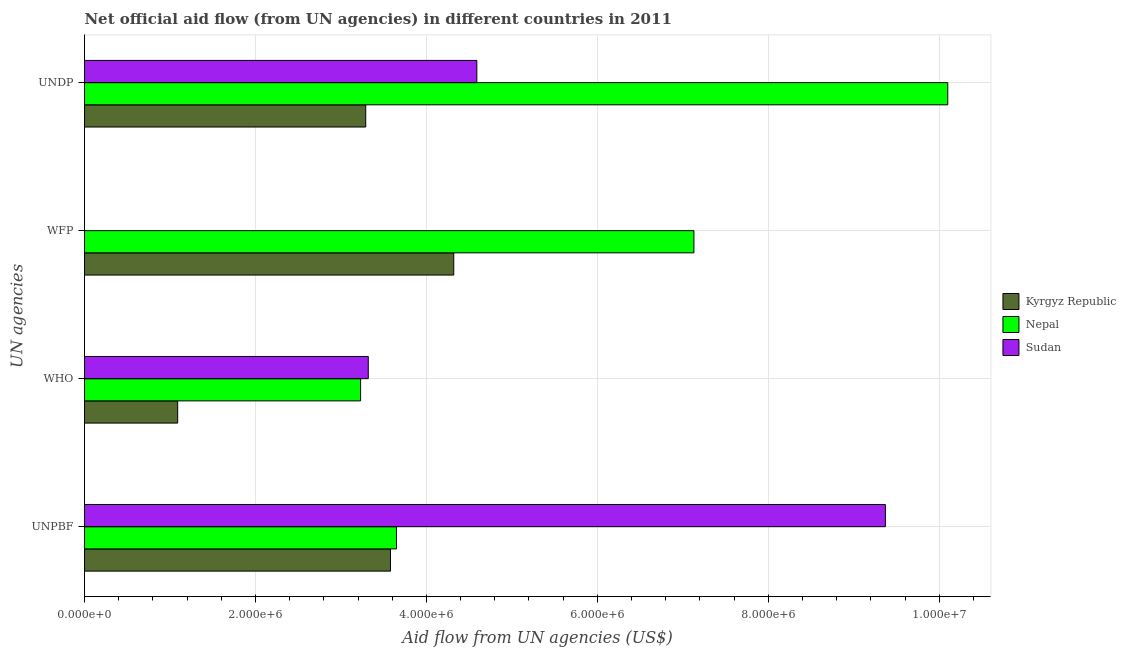How many different coloured bars are there?
Your answer should be compact. 3. Are the number of bars per tick equal to the number of legend labels?
Provide a short and direct response. No. How many bars are there on the 4th tick from the top?
Give a very brief answer. 3. How many bars are there on the 1st tick from the bottom?
Offer a terse response. 3. What is the label of the 4th group of bars from the top?
Your answer should be very brief. UNPBF. What is the amount of aid given by wfp in Sudan?
Offer a terse response. 0. Across all countries, what is the maximum amount of aid given by unpbf?
Make the answer very short. 9.37e+06. Across all countries, what is the minimum amount of aid given by unpbf?
Keep it short and to the point. 3.58e+06. In which country was the amount of aid given by undp maximum?
Ensure brevity in your answer.  Nepal. What is the total amount of aid given by unpbf in the graph?
Make the answer very short. 1.66e+07. What is the difference between the amount of aid given by unpbf in Sudan and that in Kyrgyz Republic?
Your answer should be compact. 5.79e+06. What is the difference between the amount of aid given by unpbf in Sudan and the amount of aid given by who in Nepal?
Your answer should be very brief. 6.14e+06. What is the average amount of aid given by undp per country?
Provide a short and direct response. 5.99e+06. What is the difference between the amount of aid given by undp and amount of aid given by who in Nepal?
Your response must be concise. 6.87e+06. What is the ratio of the amount of aid given by who in Nepal to that in Kyrgyz Republic?
Give a very brief answer. 2.96. Is the difference between the amount of aid given by who in Nepal and Kyrgyz Republic greater than the difference between the amount of aid given by undp in Nepal and Kyrgyz Republic?
Your response must be concise. No. What is the difference between the highest and the lowest amount of aid given by unpbf?
Offer a very short reply. 5.79e+06. Is the sum of the amount of aid given by undp in Sudan and Kyrgyz Republic greater than the maximum amount of aid given by unpbf across all countries?
Give a very brief answer. No. Is it the case that in every country, the sum of the amount of aid given by unpbf and amount of aid given by wfp is greater than the sum of amount of aid given by who and amount of aid given by undp?
Make the answer very short. No. Is it the case that in every country, the sum of the amount of aid given by unpbf and amount of aid given by who is greater than the amount of aid given by wfp?
Provide a succinct answer. No. How many countries are there in the graph?
Give a very brief answer. 3. What is the difference between two consecutive major ticks on the X-axis?
Make the answer very short. 2.00e+06. How are the legend labels stacked?
Ensure brevity in your answer.  Vertical. What is the title of the graph?
Make the answer very short. Net official aid flow (from UN agencies) in different countries in 2011. Does "Israel" appear as one of the legend labels in the graph?
Your answer should be very brief. No. What is the label or title of the X-axis?
Offer a terse response. Aid flow from UN agencies (US$). What is the label or title of the Y-axis?
Offer a very short reply. UN agencies. What is the Aid flow from UN agencies (US$) of Kyrgyz Republic in UNPBF?
Provide a succinct answer. 3.58e+06. What is the Aid flow from UN agencies (US$) in Nepal in UNPBF?
Provide a succinct answer. 3.65e+06. What is the Aid flow from UN agencies (US$) of Sudan in UNPBF?
Ensure brevity in your answer.  9.37e+06. What is the Aid flow from UN agencies (US$) in Kyrgyz Republic in WHO?
Provide a short and direct response. 1.09e+06. What is the Aid flow from UN agencies (US$) of Nepal in WHO?
Keep it short and to the point. 3.23e+06. What is the Aid flow from UN agencies (US$) of Sudan in WHO?
Offer a terse response. 3.32e+06. What is the Aid flow from UN agencies (US$) in Kyrgyz Republic in WFP?
Provide a succinct answer. 4.32e+06. What is the Aid flow from UN agencies (US$) of Nepal in WFP?
Provide a succinct answer. 7.13e+06. What is the Aid flow from UN agencies (US$) of Kyrgyz Republic in UNDP?
Provide a short and direct response. 3.29e+06. What is the Aid flow from UN agencies (US$) of Nepal in UNDP?
Provide a succinct answer. 1.01e+07. What is the Aid flow from UN agencies (US$) of Sudan in UNDP?
Make the answer very short. 4.59e+06. Across all UN agencies, what is the maximum Aid flow from UN agencies (US$) of Kyrgyz Republic?
Keep it short and to the point. 4.32e+06. Across all UN agencies, what is the maximum Aid flow from UN agencies (US$) in Nepal?
Give a very brief answer. 1.01e+07. Across all UN agencies, what is the maximum Aid flow from UN agencies (US$) of Sudan?
Offer a very short reply. 9.37e+06. Across all UN agencies, what is the minimum Aid flow from UN agencies (US$) of Kyrgyz Republic?
Give a very brief answer. 1.09e+06. Across all UN agencies, what is the minimum Aid flow from UN agencies (US$) in Nepal?
Offer a very short reply. 3.23e+06. What is the total Aid flow from UN agencies (US$) in Kyrgyz Republic in the graph?
Ensure brevity in your answer.  1.23e+07. What is the total Aid flow from UN agencies (US$) of Nepal in the graph?
Provide a short and direct response. 2.41e+07. What is the total Aid flow from UN agencies (US$) of Sudan in the graph?
Offer a very short reply. 1.73e+07. What is the difference between the Aid flow from UN agencies (US$) of Kyrgyz Republic in UNPBF and that in WHO?
Provide a succinct answer. 2.49e+06. What is the difference between the Aid flow from UN agencies (US$) of Nepal in UNPBF and that in WHO?
Offer a very short reply. 4.20e+05. What is the difference between the Aid flow from UN agencies (US$) in Sudan in UNPBF and that in WHO?
Keep it short and to the point. 6.05e+06. What is the difference between the Aid flow from UN agencies (US$) in Kyrgyz Republic in UNPBF and that in WFP?
Ensure brevity in your answer.  -7.40e+05. What is the difference between the Aid flow from UN agencies (US$) in Nepal in UNPBF and that in WFP?
Offer a terse response. -3.48e+06. What is the difference between the Aid flow from UN agencies (US$) in Kyrgyz Republic in UNPBF and that in UNDP?
Your answer should be very brief. 2.90e+05. What is the difference between the Aid flow from UN agencies (US$) in Nepal in UNPBF and that in UNDP?
Provide a succinct answer. -6.45e+06. What is the difference between the Aid flow from UN agencies (US$) in Sudan in UNPBF and that in UNDP?
Offer a very short reply. 4.78e+06. What is the difference between the Aid flow from UN agencies (US$) in Kyrgyz Republic in WHO and that in WFP?
Make the answer very short. -3.23e+06. What is the difference between the Aid flow from UN agencies (US$) in Nepal in WHO and that in WFP?
Make the answer very short. -3.90e+06. What is the difference between the Aid flow from UN agencies (US$) of Kyrgyz Republic in WHO and that in UNDP?
Offer a terse response. -2.20e+06. What is the difference between the Aid flow from UN agencies (US$) of Nepal in WHO and that in UNDP?
Provide a succinct answer. -6.87e+06. What is the difference between the Aid flow from UN agencies (US$) of Sudan in WHO and that in UNDP?
Your response must be concise. -1.27e+06. What is the difference between the Aid flow from UN agencies (US$) of Kyrgyz Republic in WFP and that in UNDP?
Offer a very short reply. 1.03e+06. What is the difference between the Aid flow from UN agencies (US$) in Nepal in WFP and that in UNDP?
Give a very brief answer. -2.97e+06. What is the difference between the Aid flow from UN agencies (US$) in Kyrgyz Republic in UNPBF and the Aid flow from UN agencies (US$) in Nepal in WHO?
Provide a short and direct response. 3.50e+05. What is the difference between the Aid flow from UN agencies (US$) of Nepal in UNPBF and the Aid flow from UN agencies (US$) of Sudan in WHO?
Your answer should be compact. 3.30e+05. What is the difference between the Aid flow from UN agencies (US$) in Kyrgyz Republic in UNPBF and the Aid flow from UN agencies (US$) in Nepal in WFP?
Keep it short and to the point. -3.55e+06. What is the difference between the Aid flow from UN agencies (US$) of Kyrgyz Republic in UNPBF and the Aid flow from UN agencies (US$) of Nepal in UNDP?
Give a very brief answer. -6.52e+06. What is the difference between the Aid flow from UN agencies (US$) of Kyrgyz Republic in UNPBF and the Aid flow from UN agencies (US$) of Sudan in UNDP?
Ensure brevity in your answer.  -1.01e+06. What is the difference between the Aid flow from UN agencies (US$) of Nepal in UNPBF and the Aid flow from UN agencies (US$) of Sudan in UNDP?
Provide a succinct answer. -9.40e+05. What is the difference between the Aid flow from UN agencies (US$) of Kyrgyz Republic in WHO and the Aid flow from UN agencies (US$) of Nepal in WFP?
Offer a very short reply. -6.04e+06. What is the difference between the Aid flow from UN agencies (US$) in Kyrgyz Republic in WHO and the Aid flow from UN agencies (US$) in Nepal in UNDP?
Ensure brevity in your answer.  -9.01e+06. What is the difference between the Aid flow from UN agencies (US$) in Kyrgyz Republic in WHO and the Aid flow from UN agencies (US$) in Sudan in UNDP?
Provide a succinct answer. -3.50e+06. What is the difference between the Aid flow from UN agencies (US$) of Nepal in WHO and the Aid flow from UN agencies (US$) of Sudan in UNDP?
Provide a short and direct response. -1.36e+06. What is the difference between the Aid flow from UN agencies (US$) of Kyrgyz Republic in WFP and the Aid flow from UN agencies (US$) of Nepal in UNDP?
Offer a terse response. -5.78e+06. What is the difference between the Aid flow from UN agencies (US$) of Nepal in WFP and the Aid flow from UN agencies (US$) of Sudan in UNDP?
Give a very brief answer. 2.54e+06. What is the average Aid flow from UN agencies (US$) of Kyrgyz Republic per UN agencies?
Provide a short and direct response. 3.07e+06. What is the average Aid flow from UN agencies (US$) in Nepal per UN agencies?
Give a very brief answer. 6.03e+06. What is the average Aid flow from UN agencies (US$) in Sudan per UN agencies?
Give a very brief answer. 4.32e+06. What is the difference between the Aid flow from UN agencies (US$) of Kyrgyz Republic and Aid flow from UN agencies (US$) of Sudan in UNPBF?
Your answer should be very brief. -5.79e+06. What is the difference between the Aid flow from UN agencies (US$) of Nepal and Aid flow from UN agencies (US$) of Sudan in UNPBF?
Your answer should be compact. -5.72e+06. What is the difference between the Aid flow from UN agencies (US$) in Kyrgyz Republic and Aid flow from UN agencies (US$) in Nepal in WHO?
Ensure brevity in your answer.  -2.14e+06. What is the difference between the Aid flow from UN agencies (US$) in Kyrgyz Republic and Aid flow from UN agencies (US$) in Sudan in WHO?
Your response must be concise. -2.23e+06. What is the difference between the Aid flow from UN agencies (US$) of Kyrgyz Republic and Aid flow from UN agencies (US$) of Nepal in WFP?
Provide a succinct answer. -2.81e+06. What is the difference between the Aid flow from UN agencies (US$) of Kyrgyz Republic and Aid flow from UN agencies (US$) of Nepal in UNDP?
Provide a short and direct response. -6.81e+06. What is the difference between the Aid flow from UN agencies (US$) in Kyrgyz Republic and Aid flow from UN agencies (US$) in Sudan in UNDP?
Your answer should be very brief. -1.30e+06. What is the difference between the Aid flow from UN agencies (US$) of Nepal and Aid flow from UN agencies (US$) of Sudan in UNDP?
Offer a very short reply. 5.51e+06. What is the ratio of the Aid flow from UN agencies (US$) of Kyrgyz Republic in UNPBF to that in WHO?
Provide a short and direct response. 3.28. What is the ratio of the Aid flow from UN agencies (US$) of Nepal in UNPBF to that in WHO?
Ensure brevity in your answer.  1.13. What is the ratio of the Aid flow from UN agencies (US$) of Sudan in UNPBF to that in WHO?
Keep it short and to the point. 2.82. What is the ratio of the Aid flow from UN agencies (US$) in Kyrgyz Republic in UNPBF to that in WFP?
Your answer should be very brief. 0.83. What is the ratio of the Aid flow from UN agencies (US$) in Nepal in UNPBF to that in WFP?
Keep it short and to the point. 0.51. What is the ratio of the Aid flow from UN agencies (US$) in Kyrgyz Republic in UNPBF to that in UNDP?
Your answer should be very brief. 1.09. What is the ratio of the Aid flow from UN agencies (US$) in Nepal in UNPBF to that in UNDP?
Provide a succinct answer. 0.36. What is the ratio of the Aid flow from UN agencies (US$) in Sudan in UNPBF to that in UNDP?
Offer a terse response. 2.04. What is the ratio of the Aid flow from UN agencies (US$) of Kyrgyz Republic in WHO to that in WFP?
Offer a very short reply. 0.25. What is the ratio of the Aid flow from UN agencies (US$) in Nepal in WHO to that in WFP?
Give a very brief answer. 0.45. What is the ratio of the Aid flow from UN agencies (US$) in Kyrgyz Republic in WHO to that in UNDP?
Provide a short and direct response. 0.33. What is the ratio of the Aid flow from UN agencies (US$) in Nepal in WHO to that in UNDP?
Provide a succinct answer. 0.32. What is the ratio of the Aid flow from UN agencies (US$) of Sudan in WHO to that in UNDP?
Provide a short and direct response. 0.72. What is the ratio of the Aid flow from UN agencies (US$) of Kyrgyz Republic in WFP to that in UNDP?
Your answer should be compact. 1.31. What is the ratio of the Aid flow from UN agencies (US$) of Nepal in WFP to that in UNDP?
Your answer should be compact. 0.71. What is the difference between the highest and the second highest Aid flow from UN agencies (US$) in Kyrgyz Republic?
Keep it short and to the point. 7.40e+05. What is the difference between the highest and the second highest Aid flow from UN agencies (US$) in Nepal?
Offer a terse response. 2.97e+06. What is the difference between the highest and the second highest Aid flow from UN agencies (US$) of Sudan?
Your answer should be compact. 4.78e+06. What is the difference between the highest and the lowest Aid flow from UN agencies (US$) in Kyrgyz Republic?
Your response must be concise. 3.23e+06. What is the difference between the highest and the lowest Aid flow from UN agencies (US$) of Nepal?
Your answer should be compact. 6.87e+06. What is the difference between the highest and the lowest Aid flow from UN agencies (US$) of Sudan?
Ensure brevity in your answer.  9.37e+06. 